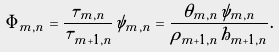Convert formula to latex. <formula><loc_0><loc_0><loc_500><loc_500>\tilde { \Phi } _ { m , n } = \frac { \tilde { \tau } _ { m , n } } { \tilde { \tau } _ { m + 1 , n } } \tilde { \psi } _ { m , n } = \frac { \theta _ { m , n } \tilde { \psi } _ { m , n } } { \rho _ { m + 1 , n } h _ { m + 1 , n } } .</formula> 